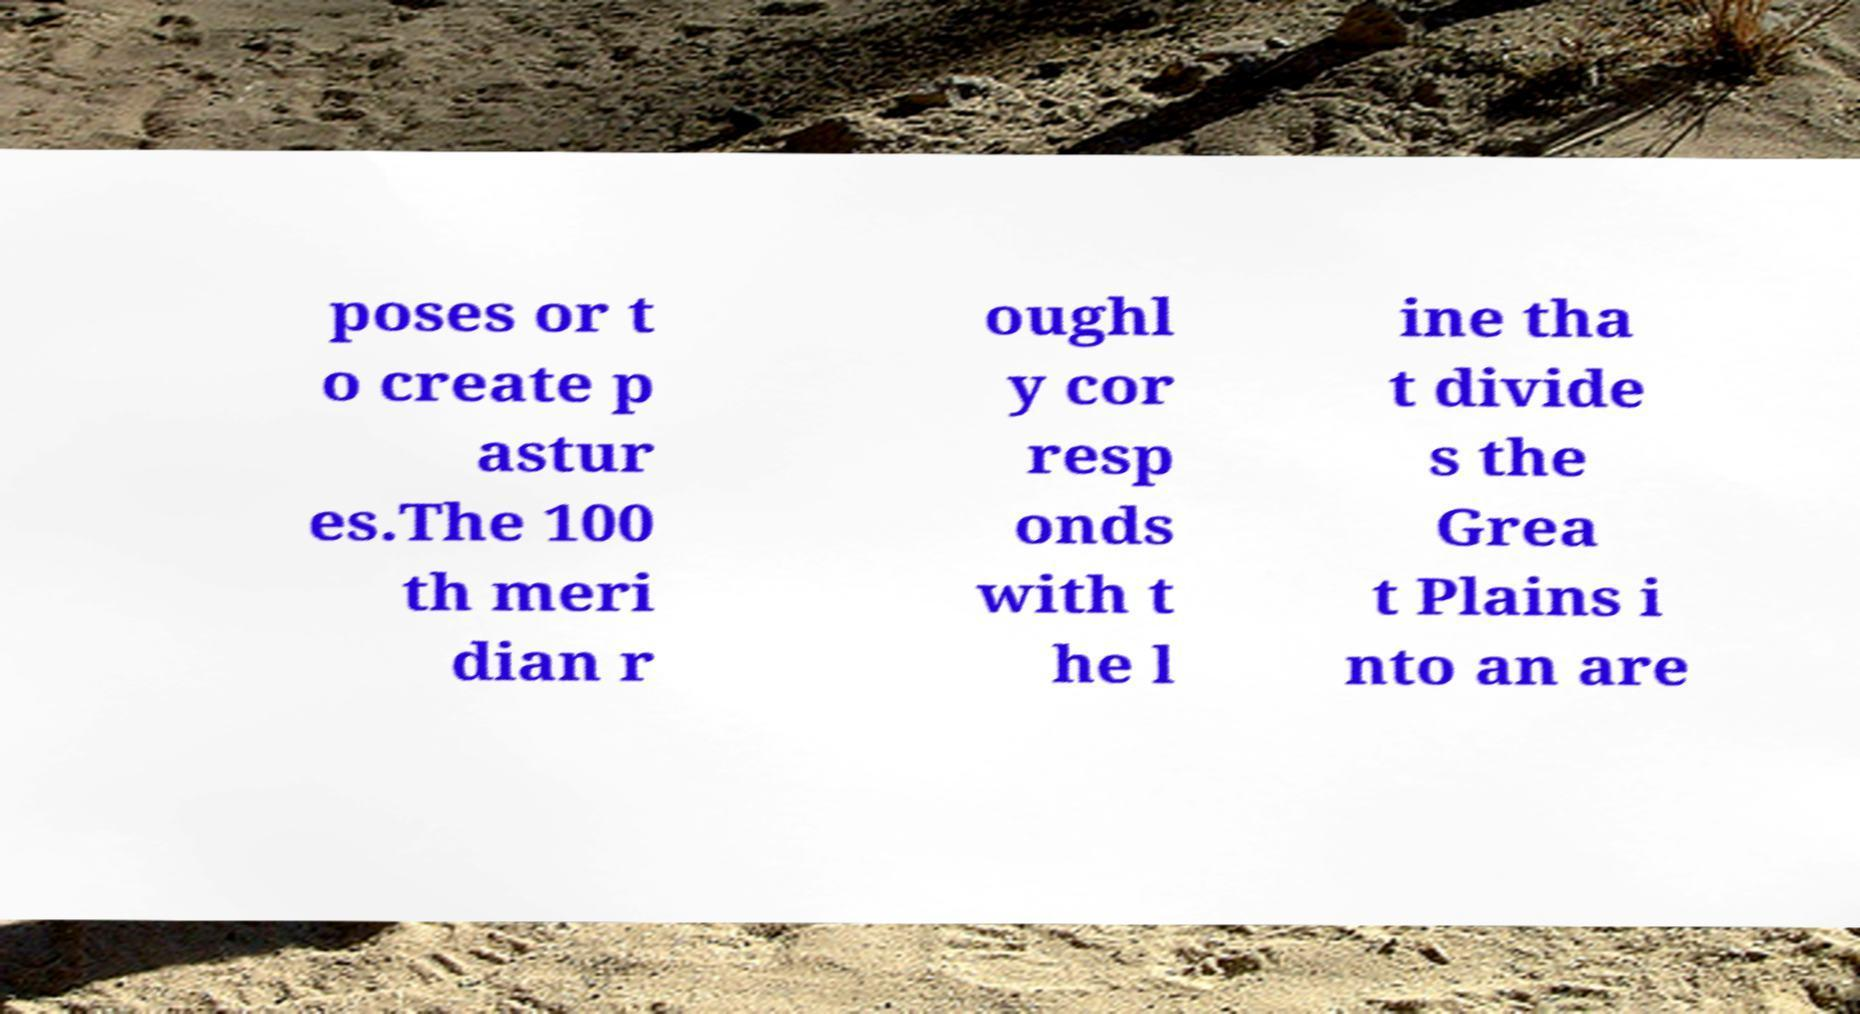Please read and relay the text visible in this image. What does it say? poses or t o create p astur es.The 100 th meri dian r oughl y cor resp onds with t he l ine tha t divide s the Grea t Plains i nto an are 